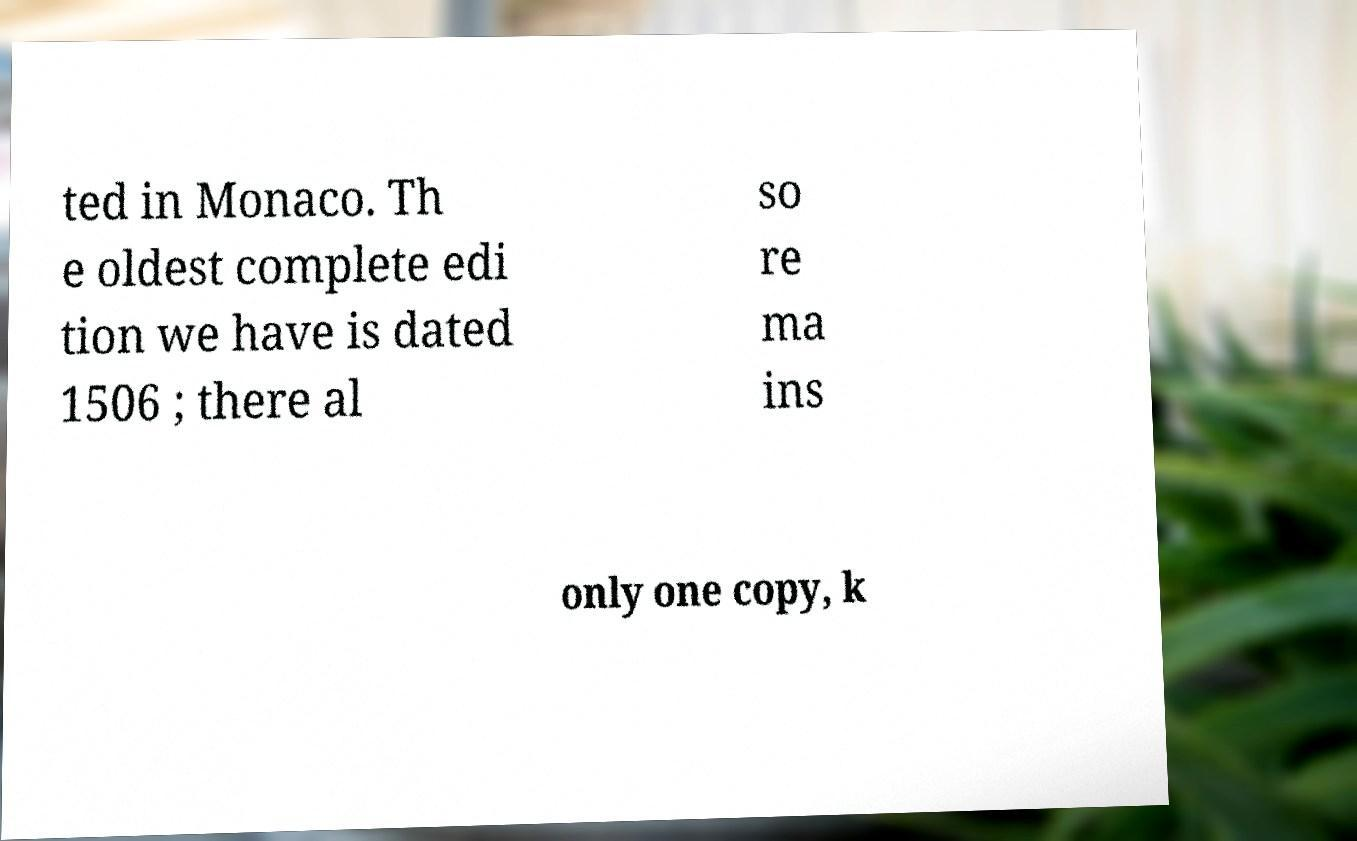Could you extract and type out the text from this image? ted in Monaco. Th e oldest complete edi tion we have is dated 1506 ; there al so re ma ins only one copy, k 